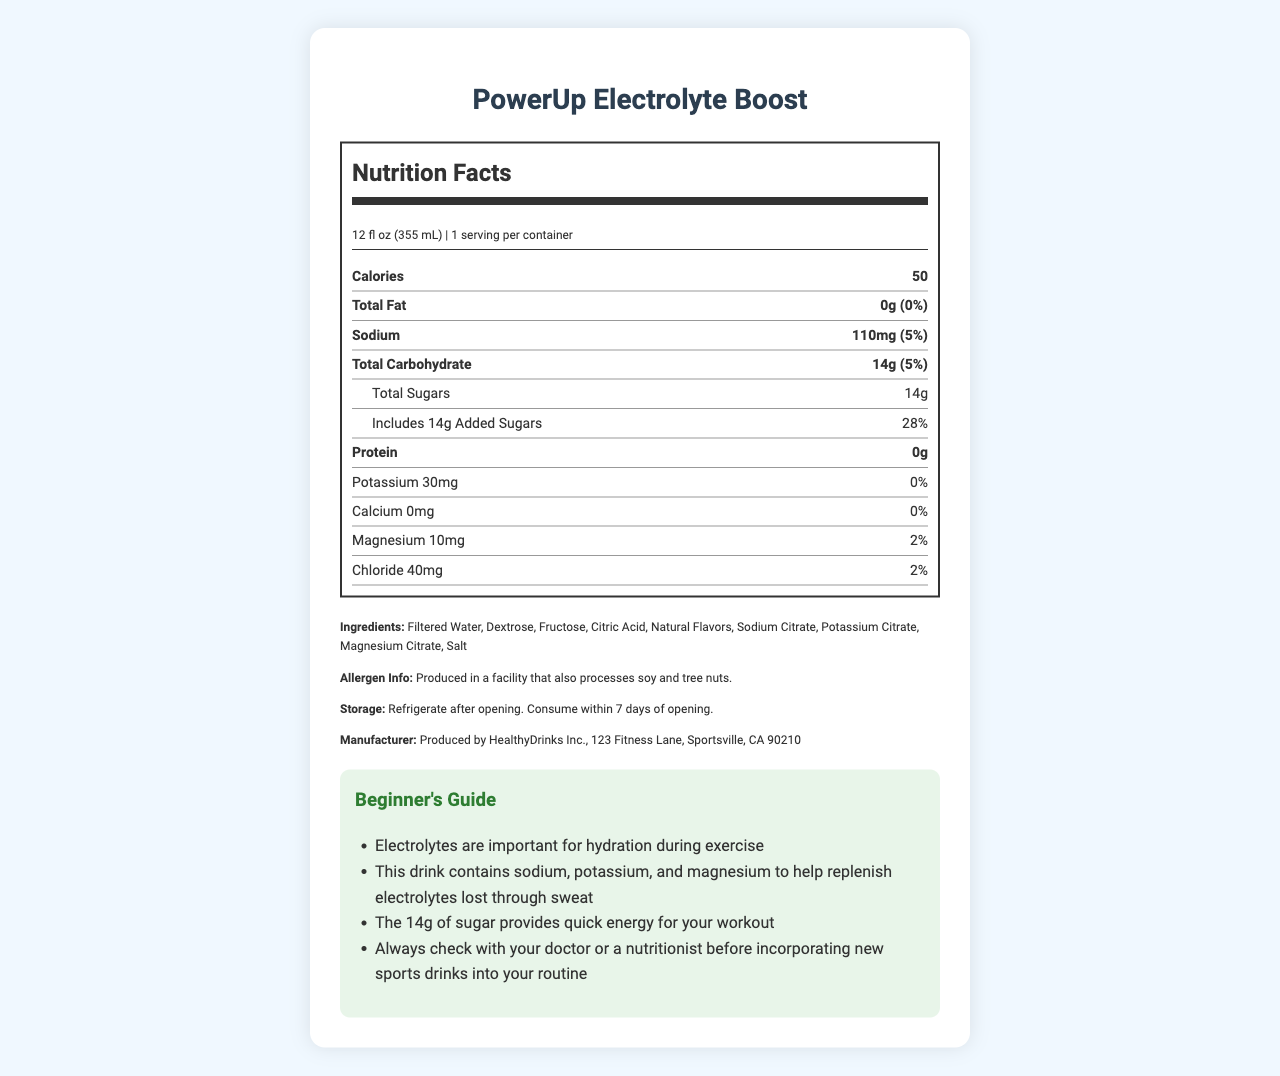what is the serving size? The serving size is listed near the top of the nutrition label and described as "12 fl oz (355 mL)".
Answer: 12 fl oz (355 mL) how many calories are in one serving? The number of calories per serving is clearly stated in the category "Calories" on the nutrition label.
Answer: 50 what are the main electrolytes in this sports drink? The main electrolytes listed in the nutrition label are sodium (110mg), potassium (30mg), magnesium (10mg), and chloride (40mg).
Answer: sodium, potassium, magnesium, chloride what percentage of your daily value of sodium does one serving of this drink provide? The daily value percentage for sodium is listed as 5% next to the sodium content.
Answer: 5% where is this product manufactured? The manufacturing information is found at the bottom of the document in the manufacturer information section.
Answer: Produced by HealthyDrinks Inc., 123 Fitness Lane, Sportsville, CA 90210 how much total sugar is in one serving of this sports drink? The total sugar content is listed under "Total Sugars" in the nutrition label as 14g.
Answer: 14g how long should you consume the drink after opening it? The storage instructions specify that the drink should be consumed within 7 days of opening.
Answer: Consume within 7 days of opening which of the following ingredients is NOT listed on the label? A. Filtered Water B. Dextrose C. Aspartame D. Citric Acid The list of ingredients includes Filtered Water, Dextrose, and Citric Acid but does not include Aspartame.
Answer: C how much protein does this sports drink contain? The protein content is listed under "Protein" in the nutrition label as 0g.
Answer: 0g what is the amount of magnesium in this sports drink? A. 0mg B. 10mg C. 30mg D. 110mg The nutrition label states that the magnesium content is 10mg.
Answer: B is this drink suitable for someone with a soy or tree nut allergy? The allergen info states that it’s produced in a facility that also processes soy and tree nuts, which poses a potential risk for those with allergies.
Answer: No what is the main idea of this document? The document outlines the key nutritional facts, ingredients, allergen information, and usage instructions for PowerUp Electrolyte Boost.
Answer: This document provides the nutritional information for PowerUp Electrolyte Boost, a sports drink that contains electrolytes like sodium, potassium, and magnesium, designed to help with hydration and provide energy during exercise. is the daily value percentage for calcium addressed in the document? The daily value percentage for calcium is listed in the nutrition label as 0%.
Answer: Yes how many servings are in one container of this sports drink? The serving size information specifies that there is 1 serving per container.
Answer: 1 how much added sugar does this drink contain? The nutrition label indicates that the added sugar content is 14g.
Answer: 14g is this product gluten-free? The document does not provide any information about whether the product is gluten-free, so this information cannot be determined from the given label.
Answer: Cannot be determined 